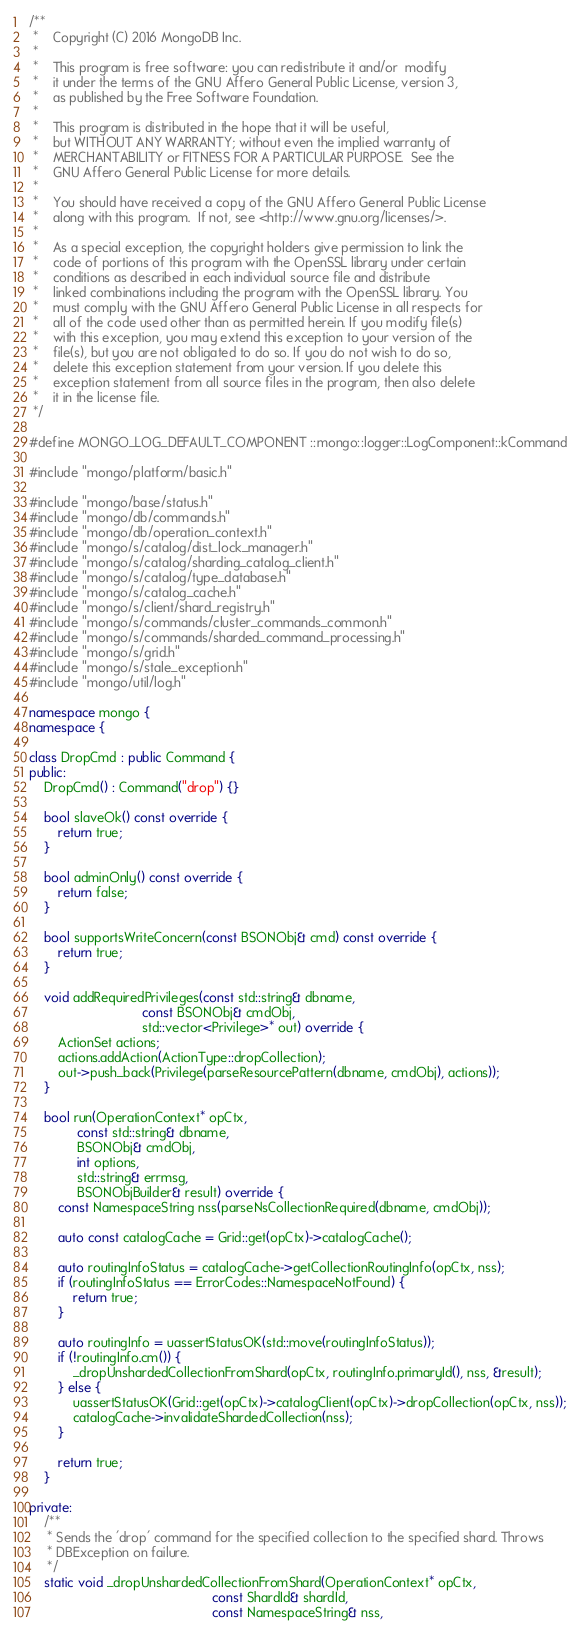<code> <loc_0><loc_0><loc_500><loc_500><_C++_>/**
 *    Copyright (C) 2016 MongoDB Inc.
 *
 *    This program is free software: you can redistribute it and/or  modify
 *    it under the terms of the GNU Affero General Public License, version 3,
 *    as published by the Free Software Foundation.
 *
 *    This program is distributed in the hope that it will be useful,
 *    but WITHOUT ANY WARRANTY; without even the implied warranty of
 *    MERCHANTABILITY or FITNESS FOR A PARTICULAR PURPOSE.  See the
 *    GNU Affero General Public License for more details.
 *
 *    You should have received a copy of the GNU Affero General Public License
 *    along with this program.  If not, see <http://www.gnu.org/licenses/>.
 *
 *    As a special exception, the copyright holders give permission to link the
 *    code of portions of this program with the OpenSSL library under certain
 *    conditions as described in each individual source file and distribute
 *    linked combinations including the program with the OpenSSL library. You
 *    must comply with the GNU Affero General Public License in all respects for
 *    all of the code used other than as permitted herein. If you modify file(s)
 *    with this exception, you may extend this exception to your version of the
 *    file(s), but you are not obligated to do so. If you do not wish to do so,
 *    delete this exception statement from your version. If you delete this
 *    exception statement from all source files in the program, then also delete
 *    it in the license file.
 */

#define MONGO_LOG_DEFAULT_COMPONENT ::mongo::logger::LogComponent::kCommand

#include "mongo/platform/basic.h"

#include "mongo/base/status.h"
#include "mongo/db/commands.h"
#include "mongo/db/operation_context.h"
#include "mongo/s/catalog/dist_lock_manager.h"
#include "mongo/s/catalog/sharding_catalog_client.h"
#include "mongo/s/catalog/type_database.h"
#include "mongo/s/catalog_cache.h"
#include "mongo/s/client/shard_registry.h"
#include "mongo/s/commands/cluster_commands_common.h"
#include "mongo/s/commands/sharded_command_processing.h"
#include "mongo/s/grid.h"
#include "mongo/s/stale_exception.h"
#include "mongo/util/log.h"

namespace mongo {
namespace {

class DropCmd : public Command {
public:
    DropCmd() : Command("drop") {}

    bool slaveOk() const override {
        return true;
    }

    bool adminOnly() const override {
        return false;
    }

    bool supportsWriteConcern(const BSONObj& cmd) const override {
        return true;
    }

    void addRequiredPrivileges(const std::string& dbname,
                               const BSONObj& cmdObj,
                               std::vector<Privilege>* out) override {
        ActionSet actions;
        actions.addAction(ActionType::dropCollection);
        out->push_back(Privilege(parseResourcePattern(dbname, cmdObj), actions));
    }

    bool run(OperationContext* opCtx,
             const std::string& dbname,
             BSONObj& cmdObj,
             int options,
             std::string& errmsg,
             BSONObjBuilder& result) override {
        const NamespaceString nss(parseNsCollectionRequired(dbname, cmdObj));

        auto const catalogCache = Grid::get(opCtx)->catalogCache();

        auto routingInfoStatus = catalogCache->getCollectionRoutingInfo(opCtx, nss);
        if (routingInfoStatus == ErrorCodes::NamespaceNotFound) {
            return true;
        }

        auto routingInfo = uassertStatusOK(std::move(routingInfoStatus));
        if (!routingInfo.cm()) {
            _dropUnshardedCollectionFromShard(opCtx, routingInfo.primaryId(), nss, &result);
        } else {
            uassertStatusOK(Grid::get(opCtx)->catalogClient(opCtx)->dropCollection(opCtx, nss));
            catalogCache->invalidateShardedCollection(nss);
        }

        return true;
    }

private:
    /**
     * Sends the 'drop' command for the specified collection to the specified shard. Throws
     * DBException on failure.
     */
    static void _dropUnshardedCollectionFromShard(OperationContext* opCtx,
                                                  const ShardId& shardId,
                                                  const NamespaceString& nss,</code> 